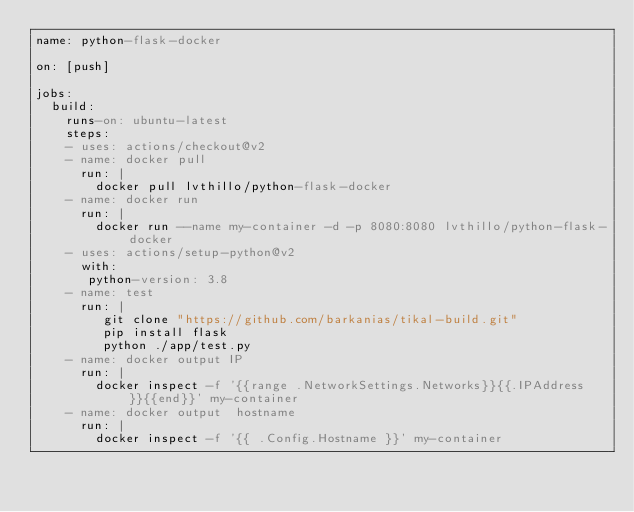<code> <loc_0><loc_0><loc_500><loc_500><_YAML_>name: python-flask-docker

on: [push]

jobs:
  build:
    runs-on: ubuntu-latest
    steps:
    - uses: actions/checkout@v2
    - name: docker pull
      run: |
        docker pull lvthillo/python-flask-docker
    - name: docker run
      run: |
        docker run --name my-container -d -p 8080:8080 lvthillo/python-flask-docker
    - uses: actions/setup-python@v2
      with: 
       python-version: 3.8
    - name: test
      run: |
         git clone "https://github.com/barkanias/tikal-build.git"
         pip install flask
         python ./app/test.py
    - name: docker output IP  
      run: |
        docker inspect -f '{{range .NetworkSettings.Networks}}{{.IPAddress}}{{end}}' my-container
    - name: docker output  hostname
      run: |
        docker inspect -f '{{ .Config.Hostname }}' my-container
</code> 